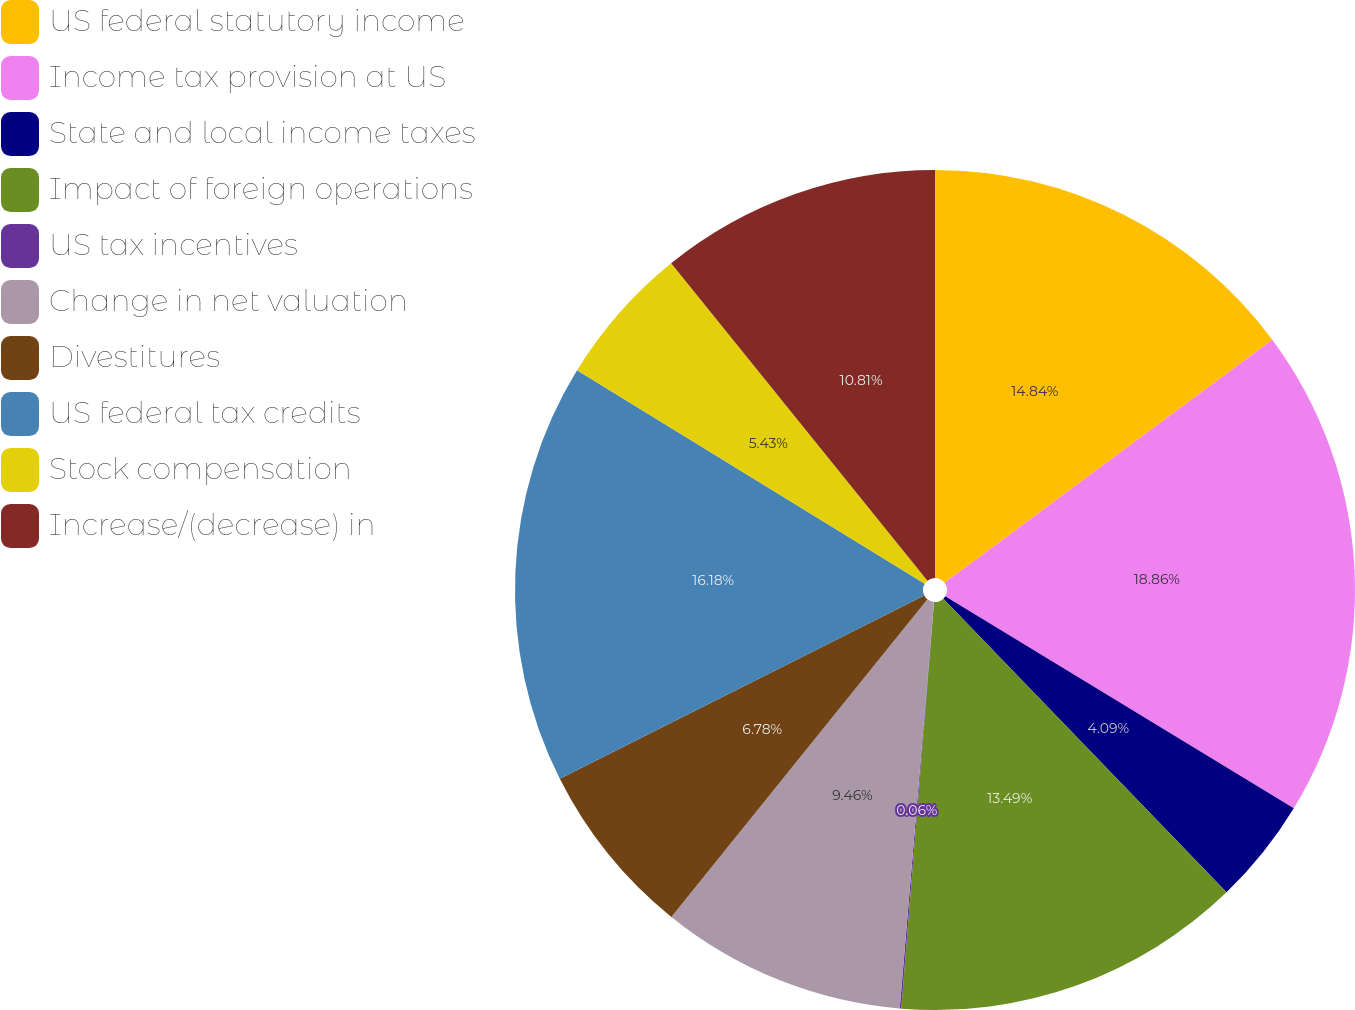Convert chart to OTSL. <chart><loc_0><loc_0><loc_500><loc_500><pie_chart><fcel>US federal statutory income<fcel>Income tax provision at US<fcel>State and local income taxes<fcel>Impact of foreign operations<fcel>US tax incentives<fcel>Change in net valuation<fcel>Divestitures<fcel>US federal tax credits<fcel>Stock compensation<fcel>Increase/(decrease) in<nl><fcel>14.84%<fcel>18.86%<fcel>4.09%<fcel>13.49%<fcel>0.06%<fcel>9.46%<fcel>6.78%<fcel>16.18%<fcel>5.43%<fcel>10.81%<nl></chart> 